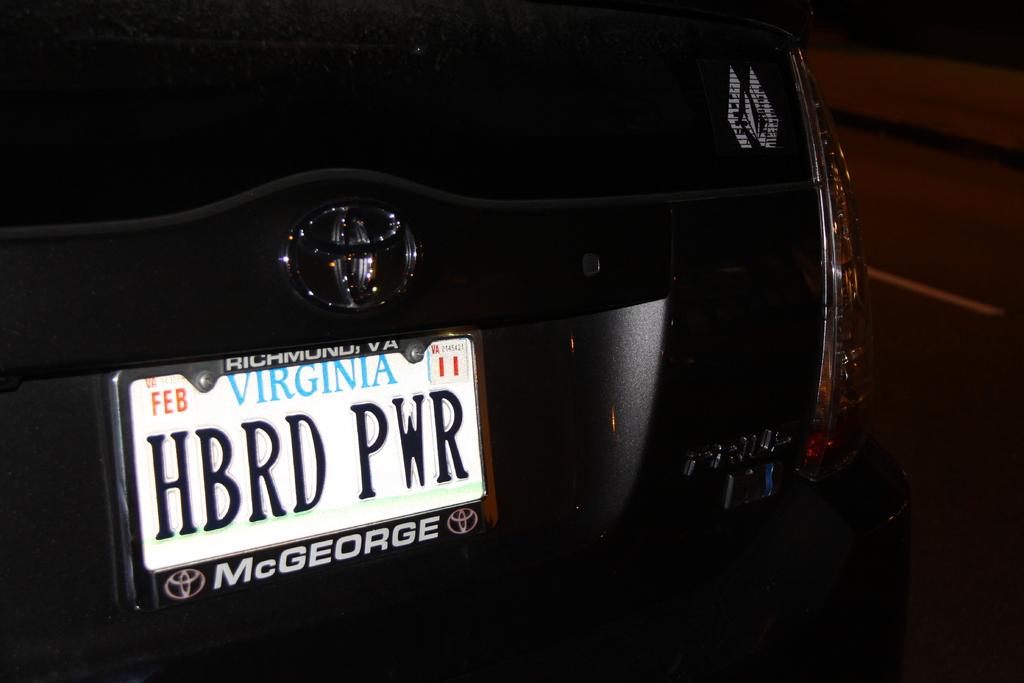What is the brand of this car?
Your answer should be very brief. Answering does not require reading text in the image. 